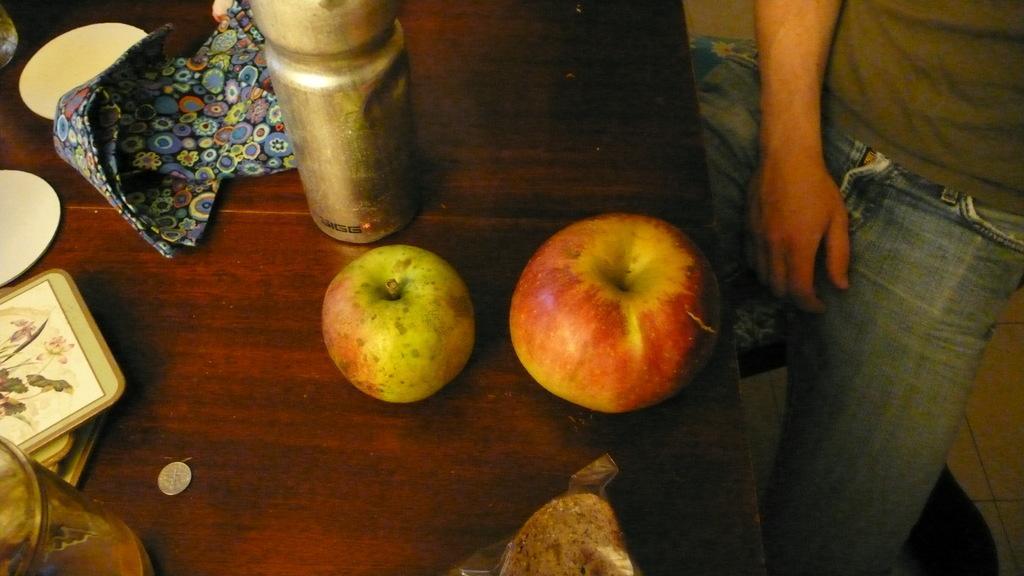Can you describe this image briefly? On a wooden table we can see apples, plates, cloth, bottle, glass, a coin, far we can see a glass object. We can see the food in a transparent packet. On the right side of the picture we can see a man and it seems like he is siting. We can see the floor. 